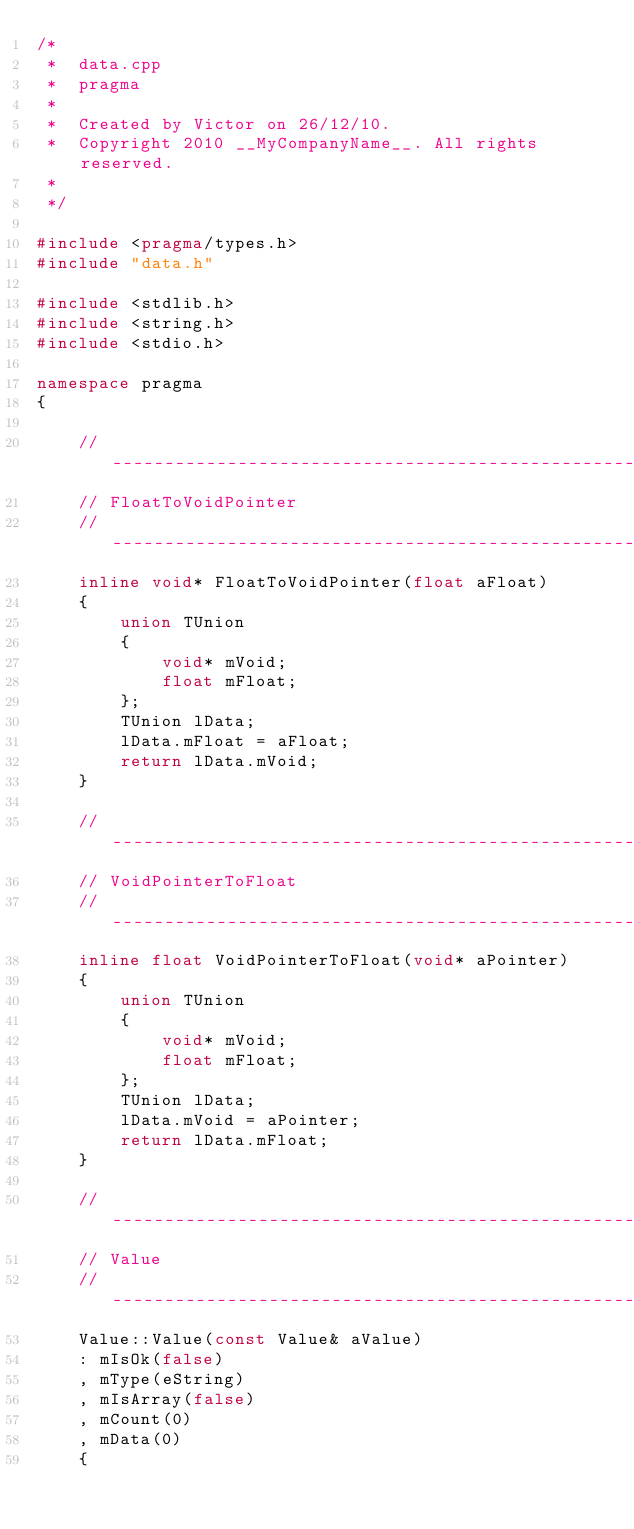Convert code to text. <code><loc_0><loc_0><loc_500><loc_500><_C++_>/*
 *  data.cpp
 *  pragma
 *
 *  Created by Victor on 26/12/10.
 *  Copyright 2010 __MyCompanyName__. All rights reserved.
 *
 */

#include <pragma/types.h>
#include "data.h"

#include <stdlib.h>
#include <string.h>
#include <stdio.h>

namespace pragma
{

	//------------------------------------------------------------------------------------------------------------------
	// FloatToVoidPointer
	//------------------------------------------------------------------------------------------------------------------
	inline void* FloatToVoidPointer(float aFloat)
	{
		union TUnion
		{
			void* mVoid;
			float mFloat;
		};
		TUnion lData;
		lData.mFloat = aFloat;
		return lData.mVoid;
	}

	//------------------------------------------------------------------------------------------------------------------
	// VoidPointerToFloat
	//------------------------------------------------------------------------------------------------------------------
	inline float VoidPointerToFloat(void* aPointer)
	{
		union TUnion
		{
			void* mVoid;
			float mFloat;
		};
		TUnion lData;
		lData.mVoid = aPointer;
		return lData.mFloat;
	}

	//------------------------------------------------------------------------------------------------------------------
	// Value
	//------------------------------------------------------------------------------------------------------------------
	Value::Value(const Value& aValue)
	: mIsOk(false)
	, mType(eString)
	, mIsArray(false)
	, mCount(0)
	, mData(0) 
	{</code> 